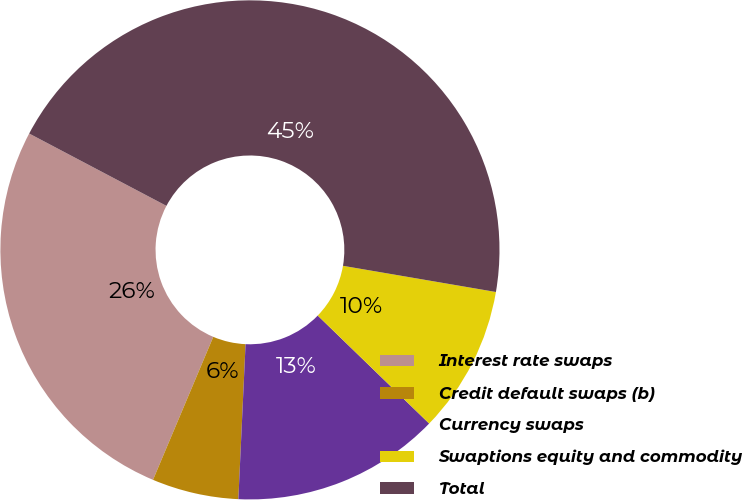Convert chart to OTSL. <chart><loc_0><loc_0><loc_500><loc_500><pie_chart><fcel>Interest rate swaps<fcel>Credit default swaps (b)<fcel>Currency swaps<fcel>Swaptions equity and commodity<fcel>Total<nl><fcel>26.37%<fcel>5.61%<fcel>13.49%<fcel>9.55%<fcel>44.98%<nl></chart> 